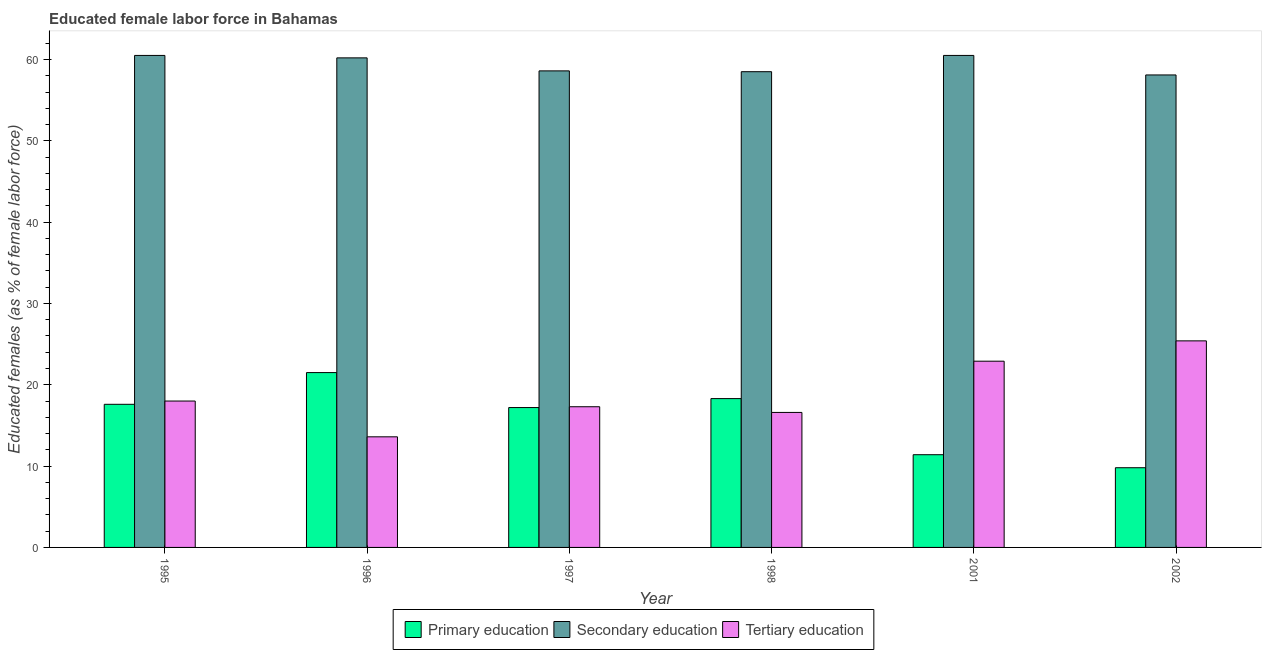Are the number of bars on each tick of the X-axis equal?
Provide a succinct answer. Yes. What is the label of the 6th group of bars from the left?
Ensure brevity in your answer.  2002. What is the percentage of female labor force who received primary education in 1997?
Make the answer very short. 17.2. Across all years, what is the maximum percentage of female labor force who received secondary education?
Keep it short and to the point. 60.5. Across all years, what is the minimum percentage of female labor force who received primary education?
Your response must be concise. 9.8. In which year was the percentage of female labor force who received primary education minimum?
Your answer should be very brief. 2002. What is the total percentage of female labor force who received primary education in the graph?
Offer a terse response. 95.8. What is the difference between the percentage of female labor force who received tertiary education in 1996 and that in 1998?
Provide a short and direct response. -3. What is the average percentage of female labor force who received secondary education per year?
Offer a terse response. 59.4. In how many years, is the percentage of female labor force who received primary education greater than 46 %?
Your answer should be compact. 0. What is the ratio of the percentage of female labor force who received primary education in 1995 to that in 1996?
Give a very brief answer. 0.82. Is the percentage of female labor force who received primary education in 1995 less than that in 2001?
Give a very brief answer. No. Is the difference between the percentage of female labor force who received primary education in 1997 and 1998 greater than the difference between the percentage of female labor force who received secondary education in 1997 and 1998?
Ensure brevity in your answer.  No. What is the difference between the highest and the second highest percentage of female labor force who received primary education?
Keep it short and to the point. 3.2. What is the difference between the highest and the lowest percentage of female labor force who received tertiary education?
Make the answer very short. 11.8. In how many years, is the percentage of female labor force who received primary education greater than the average percentage of female labor force who received primary education taken over all years?
Your answer should be very brief. 4. What does the 3rd bar from the left in 1998 represents?
Offer a very short reply. Tertiary education. What does the 1st bar from the right in 1995 represents?
Provide a short and direct response. Tertiary education. Is it the case that in every year, the sum of the percentage of female labor force who received primary education and percentage of female labor force who received secondary education is greater than the percentage of female labor force who received tertiary education?
Ensure brevity in your answer.  Yes. Are all the bars in the graph horizontal?
Your response must be concise. No. Are the values on the major ticks of Y-axis written in scientific E-notation?
Your answer should be compact. No. Does the graph contain any zero values?
Ensure brevity in your answer.  No. Does the graph contain grids?
Make the answer very short. No. How many legend labels are there?
Offer a very short reply. 3. How are the legend labels stacked?
Offer a very short reply. Horizontal. What is the title of the graph?
Provide a succinct answer. Educated female labor force in Bahamas. What is the label or title of the Y-axis?
Your answer should be compact. Educated females (as % of female labor force). What is the Educated females (as % of female labor force) of Primary education in 1995?
Provide a short and direct response. 17.6. What is the Educated females (as % of female labor force) of Secondary education in 1995?
Your response must be concise. 60.5. What is the Educated females (as % of female labor force) of Tertiary education in 1995?
Provide a succinct answer. 18. What is the Educated females (as % of female labor force) in Primary education in 1996?
Offer a terse response. 21.5. What is the Educated females (as % of female labor force) in Secondary education in 1996?
Ensure brevity in your answer.  60.2. What is the Educated females (as % of female labor force) of Tertiary education in 1996?
Ensure brevity in your answer.  13.6. What is the Educated females (as % of female labor force) in Primary education in 1997?
Make the answer very short. 17.2. What is the Educated females (as % of female labor force) in Secondary education in 1997?
Provide a short and direct response. 58.6. What is the Educated females (as % of female labor force) of Tertiary education in 1997?
Give a very brief answer. 17.3. What is the Educated females (as % of female labor force) in Primary education in 1998?
Your answer should be very brief. 18.3. What is the Educated females (as % of female labor force) in Secondary education in 1998?
Offer a terse response. 58.5. What is the Educated females (as % of female labor force) of Tertiary education in 1998?
Offer a very short reply. 16.6. What is the Educated females (as % of female labor force) of Primary education in 2001?
Make the answer very short. 11.4. What is the Educated females (as % of female labor force) of Secondary education in 2001?
Your response must be concise. 60.5. What is the Educated females (as % of female labor force) of Tertiary education in 2001?
Your answer should be compact. 22.9. What is the Educated females (as % of female labor force) of Primary education in 2002?
Make the answer very short. 9.8. What is the Educated females (as % of female labor force) of Secondary education in 2002?
Your answer should be compact. 58.1. What is the Educated females (as % of female labor force) in Tertiary education in 2002?
Your response must be concise. 25.4. Across all years, what is the maximum Educated females (as % of female labor force) of Primary education?
Your answer should be very brief. 21.5. Across all years, what is the maximum Educated females (as % of female labor force) in Secondary education?
Your answer should be very brief. 60.5. Across all years, what is the maximum Educated females (as % of female labor force) in Tertiary education?
Make the answer very short. 25.4. Across all years, what is the minimum Educated females (as % of female labor force) of Primary education?
Offer a terse response. 9.8. Across all years, what is the minimum Educated females (as % of female labor force) of Secondary education?
Your response must be concise. 58.1. Across all years, what is the minimum Educated females (as % of female labor force) in Tertiary education?
Your answer should be compact. 13.6. What is the total Educated females (as % of female labor force) of Primary education in the graph?
Your response must be concise. 95.8. What is the total Educated females (as % of female labor force) in Secondary education in the graph?
Ensure brevity in your answer.  356.4. What is the total Educated females (as % of female labor force) in Tertiary education in the graph?
Provide a short and direct response. 113.8. What is the difference between the Educated females (as % of female labor force) of Primary education in 1995 and that in 1997?
Provide a succinct answer. 0.4. What is the difference between the Educated females (as % of female labor force) of Secondary education in 1995 and that in 1997?
Offer a terse response. 1.9. What is the difference between the Educated females (as % of female labor force) of Tertiary education in 1995 and that in 1997?
Offer a terse response. 0.7. What is the difference between the Educated females (as % of female labor force) in Secondary education in 1995 and that in 1998?
Your answer should be compact. 2. What is the difference between the Educated females (as % of female labor force) in Tertiary education in 1995 and that in 1998?
Your response must be concise. 1.4. What is the difference between the Educated females (as % of female labor force) in Tertiary education in 1995 and that in 2001?
Ensure brevity in your answer.  -4.9. What is the difference between the Educated females (as % of female labor force) in Primary education in 1996 and that in 1997?
Your answer should be compact. 4.3. What is the difference between the Educated females (as % of female labor force) in Tertiary education in 1996 and that in 1997?
Your answer should be very brief. -3.7. What is the difference between the Educated females (as % of female labor force) of Primary education in 1996 and that in 1998?
Your answer should be very brief. 3.2. What is the difference between the Educated females (as % of female labor force) of Primary education in 1996 and that in 2001?
Your answer should be very brief. 10.1. What is the difference between the Educated females (as % of female labor force) in Secondary education in 1996 and that in 2001?
Make the answer very short. -0.3. What is the difference between the Educated females (as % of female labor force) in Tertiary education in 1996 and that in 2001?
Offer a terse response. -9.3. What is the difference between the Educated females (as % of female labor force) of Primary education in 1996 and that in 2002?
Make the answer very short. 11.7. What is the difference between the Educated females (as % of female labor force) in Secondary education in 1996 and that in 2002?
Provide a succinct answer. 2.1. What is the difference between the Educated females (as % of female labor force) in Secondary education in 1997 and that in 1998?
Provide a short and direct response. 0.1. What is the difference between the Educated females (as % of female labor force) of Tertiary education in 1997 and that in 1998?
Your response must be concise. 0.7. What is the difference between the Educated females (as % of female labor force) of Secondary education in 1997 and that in 2001?
Provide a succinct answer. -1.9. What is the difference between the Educated females (as % of female labor force) of Tertiary education in 1997 and that in 2001?
Provide a short and direct response. -5.6. What is the difference between the Educated females (as % of female labor force) of Primary education in 1997 and that in 2002?
Your response must be concise. 7.4. What is the difference between the Educated females (as % of female labor force) of Secondary education in 1997 and that in 2002?
Offer a terse response. 0.5. What is the difference between the Educated females (as % of female labor force) in Tertiary education in 1998 and that in 2001?
Keep it short and to the point. -6.3. What is the difference between the Educated females (as % of female labor force) in Primary education in 1998 and that in 2002?
Make the answer very short. 8.5. What is the difference between the Educated females (as % of female labor force) of Secondary education in 2001 and that in 2002?
Ensure brevity in your answer.  2.4. What is the difference between the Educated females (as % of female labor force) of Tertiary education in 2001 and that in 2002?
Your response must be concise. -2.5. What is the difference between the Educated females (as % of female labor force) of Primary education in 1995 and the Educated females (as % of female labor force) of Secondary education in 1996?
Your answer should be compact. -42.6. What is the difference between the Educated females (as % of female labor force) of Primary education in 1995 and the Educated females (as % of female labor force) of Tertiary education in 1996?
Provide a succinct answer. 4. What is the difference between the Educated females (as % of female labor force) in Secondary education in 1995 and the Educated females (as % of female labor force) in Tertiary education in 1996?
Make the answer very short. 46.9. What is the difference between the Educated females (as % of female labor force) in Primary education in 1995 and the Educated females (as % of female labor force) in Secondary education in 1997?
Provide a succinct answer. -41. What is the difference between the Educated females (as % of female labor force) in Primary education in 1995 and the Educated females (as % of female labor force) in Tertiary education in 1997?
Give a very brief answer. 0.3. What is the difference between the Educated females (as % of female labor force) of Secondary education in 1995 and the Educated females (as % of female labor force) of Tertiary education in 1997?
Your answer should be compact. 43.2. What is the difference between the Educated females (as % of female labor force) in Primary education in 1995 and the Educated females (as % of female labor force) in Secondary education in 1998?
Offer a very short reply. -40.9. What is the difference between the Educated females (as % of female labor force) in Primary education in 1995 and the Educated females (as % of female labor force) in Tertiary education in 1998?
Your answer should be compact. 1. What is the difference between the Educated females (as % of female labor force) in Secondary education in 1995 and the Educated females (as % of female labor force) in Tertiary education in 1998?
Offer a terse response. 43.9. What is the difference between the Educated females (as % of female labor force) in Primary education in 1995 and the Educated females (as % of female labor force) in Secondary education in 2001?
Your response must be concise. -42.9. What is the difference between the Educated females (as % of female labor force) in Primary education in 1995 and the Educated females (as % of female labor force) in Tertiary education in 2001?
Keep it short and to the point. -5.3. What is the difference between the Educated females (as % of female labor force) of Secondary education in 1995 and the Educated females (as % of female labor force) of Tertiary education in 2001?
Your answer should be compact. 37.6. What is the difference between the Educated females (as % of female labor force) in Primary education in 1995 and the Educated females (as % of female labor force) in Secondary education in 2002?
Your answer should be very brief. -40.5. What is the difference between the Educated females (as % of female labor force) of Primary education in 1995 and the Educated females (as % of female labor force) of Tertiary education in 2002?
Give a very brief answer. -7.8. What is the difference between the Educated females (as % of female labor force) in Secondary education in 1995 and the Educated females (as % of female labor force) in Tertiary education in 2002?
Ensure brevity in your answer.  35.1. What is the difference between the Educated females (as % of female labor force) of Primary education in 1996 and the Educated females (as % of female labor force) of Secondary education in 1997?
Offer a very short reply. -37.1. What is the difference between the Educated females (as % of female labor force) in Secondary education in 1996 and the Educated females (as % of female labor force) in Tertiary education in 1997?
Make the answer very short. 42.9. What is the difference between the Educated females (as % of female labor force) of Primary education in 1996 and the Educated females (as % of female labor force) of Secondary education in 1998?
Your response must be concise. -37. What is the difference between the Educated females (as % of female labor force) in Secondary education in 1996 and the Educated females (as % of female labor force) in Tertiary education in 1998?
Offer a terse response. 43.6. What is the difference between the Educated females (as % of female labor force) in Primary education in 1996 and the Educated females (as % of female labor force) in Secondary education in 2001?
Your answer should be compact. -39. What is the difference between the Educated females (as % of female labor force) in Primary education in 1996 and the Educated females (as % of female labor force) in Tertiary education in 2001?
Offer a terse response. -1.4. What is the difference between the Educated females (as % of female labor force) in Secondary education in 1996 and the Educated females (as % of female labor force) in Tertiary education in 2001?
Your response must be concise. 37.3. What is the difference between the Educated females (as % of female labor force) of Primary education in 1996 and the Educated females (as % of female labor force) of Secondary education in 2002?
Ensure brevity in your answer.  -36.6. What is the difference between the Educated females (as % of female labor force) of Secondary education in 1996 and the Educated females (as % of female labor force) of Tertiary education in 2002?
Provide a short and direct response. 34.8. What is the difference between the Educated females (as % of female labor force) in Primary education in 1997 and the Educated females (as % of female labor force) in Secondary education in 1998?
Give a very brief answer. -41.3. What is the difference between the Educated females (as % of female labor force) of Primary education in 1997 and the Educated females (as % of female labor force) of Tertiary education in 1998?
Your response must be concise. 0.6. What is the difference between the Educated females (as % of female labor force) of Primary education in 1997 and the Educated females (as % of female labor force) of Secondary education in 2001?
Your answer should be very brief. -43.3. What is the difference between the Educated females (as % of female labor force) in Secondary education in 1997 and the Educated females (as % of female labor force) in Tertiary education in 2001?
Your answer should be very brief. 35.7. What is the difference between the Educated females (as % of female labor force) in Primary education in 1997 and the Educated females (as % of female labor force) in Secondary education in 2002?
Offer a very short reply. -40.9. What is the difference between the Educated females (as % of female labor force) of Primary education in 1997 and the Educated females (as % of female labor force) of Tertiary education in 2002?
Provide a succinct answer. -8.2. What is the difference between the Educated females (as % of female labor force) of Secondary education in 1997 and the Educated females (as % of female labor force) of Tertiary education in 2002?
Your answer should be very brief. 33.2. What is the difference between the Educated females (as % of female labor force) of Primary education in 1998 and the Educated females (as % of female labor force) of Secondary education in 2001?
Give a very brief answer. -42.2. What is the difference between the Educated females (as % of female labor force) of Secondary education in 1998 and the Educated females (as % of female labor force) of Tertiary education in 2001?
Your response must be concise. 35.6. What is the difference between the Educated females (as % of female labor force) in Primary education in 1998 and the Educated females (as % of female labor force) in Secondary education in 2002?
Offer a very short reply. -39.8. What is the difference between the Educated females (as % of female labor force) of Secondary education in 1998 and the Educated females (as % of female labor force) of Tertiary education in 2002?
Give a very brief answer. 33.1. What is the difference between the Educated females (as % of female labor force) in Primary education in 2001 and the Educated females (as % of female labor force) in Secondary education in 2002?
Ensure brevity in your answer.  -46.7. What is the difference between the Educated females (as % of female labor force) of Primary education in 2001 and the Educated females (as % of female labor force) of Tertiary education in 2002?
Your response must be concise. -14. What is the difference between the Educated females (as % of female labor force) in Secondary education in 2001 and the Educated females (as % of female labor force) in Tertiary education in 2002?
Offer a terse response. 35.1. What is the average Educated females (as % of female labor force) of Primary education per year?
Provide a short and direct response. 15.97. What is the average Educated females (as % of female labor force) of Secondary education per year?
Make the answer very short. 59.4. What is the average Educated females (as % of female labor force) in Tertiary education per year?
Make the answer very short. 18.97. In the year 1995, what is the difference between the Educated females (as % of female labor force) in Primary education and Educated females (as % of female labor force) in Secondary education?
Provide a succinct answer. -42.9. In the year 1995, what is the difference between the Educated females (as % of female labor force) in Primary education and Educated females (as % of female labor force) in Tertiary education?
Your answer should be very brief. -0.4. In the year 1995, what is the difference between the Educated females (as % of female labor force) of Secondary education and Educated females (as % of female labor force) of Tertiary education?
Give a very brief answer. 42.5. In the year 1996, what is the difference between the Educated females (as % of female labor force) in Primary education and Educated females (as % of female labor force) in Secondary education?
Provide a short and direct response. -38.7. In the year 1996, what is the difference between the Educated females (as % of female labor force) of Primary education and Educated females (as % of female labor force) of Tertiary education?
Ensure brevity in your answer.  7.9. In the year 1996, what is the difference between the Educated females (as % of female labor force) of Secondary education and Educated females (as % of female labor force) of Tertiary education?
Provide a short and direct response. 46.6. In the year 1997, what is the difference between the Educated females (as % of female labor force) of Primary education and Educated females (as % of female labor force) of Secondary education?
Give a very brief answer. -41.4. In the year 1997, what is the difference between the Educated females (as % of female labor force) of Primary education and Educated females (as % of female labor force) of Tertiary education?
Give a very brief answer. -0.1. In the year 1997, what is the difference between the Educated females (as % of female labor force) of Secondary education and Educated females (as % of female labor force) of Tertiary education?
Your answer should be very brief. 41.3. In the year 1998, what is the difference between the Educated females (as % of female labor force) in Primary education and Educated females (as % of female labor force) in Secondary education?
Provide a short and direct response. -40.2. In the year 1998, what is the difference between the Educated females (as % of female labor force) in Primary education and Educated females (as % of female labor force) in Tertiary education?
Make the answer very short. 1.7. In the year 1998, what is the difference between the Educated females (as % of female labor force) of Secondary education and Educated females (as % of female labor force) of Tertiary education?
Keep it short and to the point. 41.9. In the year 2001, what is the difference between the Educated females (as % of female labor force) in Primary education and Educated females (as % of female labor force) in Secondary education?
Your response must be concise. -49.1. In the year 2001, what is the difference between the Educated females (as % of female labor force) in Primary education and Educated females (as % of female labor force) in Tertiary education?
Your answer should be compact. -11.5. In the year 2001, what is the difference between the Educated females (as % of female labor force) in Secondary education and Educated females (as % of female labor force) in Tertiary education?
Offer a very short reply. 37.6. In the year 2002, what is the difference between the Educated females (as % of female labor force) of Primary education and Educated females (as % of female labor force) of Secondary education?
Offer a very short reply. -48.3. In the year 2002, what is the difference between the Educated females (as % of female labor force) in Primary education and Educated females (as % of female labor force) in Tertiary education?
Make the answer very short. -15.6. In the year 2002, what is the difference between the Educated females (as % of female labor force) in Secondary education and Educated females (as % of female labor force) in Tertiary education?
Your answer should be compact. 32.7. What is the ratio of the Educated females (as % of female labor force) in Primary education in 1995 to that in 1996?
Offer a very short reply. 0.82. What is the ratio of the Educated females (as % of female labor force) of Tertiary education in 1995 to that in 1996?
Keep it short and to the point. 1.32. What is the ratio of the Educated females (as % of female labor force) in Primary education in 1995 to that in 1997?
Make the answer very short. 1.02. What is the ratio of the Educated females (as % of female labor force) of Secondary education in 1995 to that in 1997?
Offer a terse response. 1.03. What is the ratio of the Educated females (as % of female labor force) in Tertiary education in 1995 to that in 1997?
Provide a succinct answer. 1.04. What is the ratio of the Educated females (as % of female labor force) of Primary education in 1995 to that in 1998?
Offer a very short reply. 0.96. What is the ratio of the Educated females (as % of female labor force) of Secondary education in 1995 to that in 1998?
Your response must be concise. 1.03. What is the ratio of the Educated females (as % of female labor force) in Tertiary education in 1995 to that in 1998?
Provide a succinct answer. 1.08. What is the ratio of the Educated females (as % of female labor force) in Primary education in 1995 to that in 2001?
Your answer should be compact. 1.54. What is the ratio of the Educated females (as % of female labor force) of Tertiary education in 1995 to that in 2001?
Provide a succinct answer. 0.79. What is the ratio of the Educated females (as % of female labor force) of Primary education in 1995 to that in 2002?
Provide a short and direct response. 1.8. What is the ratio of the Educated females (as % of female labor force) in Secondary education in 1995 to that in 2002?
Offer a very short reply. 1.04. What is the ratio of the Educated females (as % of female labor force) of Tertiary education in 1995 to that in 2002?
Ensure brevity in your answer.  0.71. What is the ratio of the Educated females (as % of female labor force) of Secondary education in 1996 to that in 1997?
Your response must be concise. 1.03. What is the ratio of the Educated females (as % of female labor force) of Tertiary education in 1996 to that in 1997?
Provide a short and direct response. 0.79. What is the ratio of the Educated females (as % of female labor force) of Primary education in 1996 to that in 1998?
Offer a terse response. 1.17. What is the ratio of the Educated females (as % of female labor force) in Secondary education in 1996 to that in 1998?
Your answer should be compact. 1.03. What is the ratio of the Educated females (as % of female labor force) in Tertiary education in 1996 to that in 1998?
Your response must be concise. 0.82. What is the ratio of the Educated females (as % of female labor force) of Primary education in 1996 to that in 2001?
Your answer should be compact. 1.89. What is the ratio of the Educated females (as % of female labor force) in Tertiary education in 1996 to that in 2001?
Provide a short and direct response. 0.59. What is the ratio of the Educated females (as % of female labor force) of Primary education in 1996 to that in 2002?
Give a very brief answer. 2.19. What is the ratio of the Educated females (as % of female labor force) in Secondary education in 1996 to that in 2002?
Make the answer very short. 1.04. What is the ratio of the Educated females (as % of female labor force) of Tertiary education in 1996 to that in 2002?
Provide a succinct answer. 0.54. What is the ratio of the Educated females (as % of female labor force) in Primary education in 1997 to that in 1998?
Keep it short and to the point. 0.94. What is the ratio of the Educated females (as % of female labor force) in Tertiary education in 1997 to that in 1998?
Provide a short and direct response. 1.04. What is the ratio of the Educated females (as % of female labor force) in Primary education in 1997 to that in 2001?
Your answer should be very brief. 1.51. What is the ratio of the Educated females (as % of female labor force) of Secondary education in 1997 to that in 2001?
Offer a very short reply. 0.97. What is the ratio of the Educated females (as % of female labor force) of Tertiary education in 1997 to that in 2001?
Make the answer very short. 0.76. What is the ratio of the Educated females (as % of female labor force) in Primary education in 1997 to that in 2002?
Offer a terse response. 1.76. What is the ratio of the Educated females (as % of female labor force) of Secondary education in 1997 to that in 2002?
Offer a terse response. 1.01. What is the ratio of the Educated females (as % of female labor force) of Tertiary education in 1997 to that in 2002?
Keep it short and to the point. 0.68. What is the ratio of the Educated females (as % of female labor force) of Primary education in 1998 to that in 2001?
Offer a very short reply. 1.61. What is the ratio of the Educated females (as % of female labor force) in Secondary education in 1998 to that in 2001?
Your response must be concise. 0.97. What is the ratio of the Educated females (as % of female labor force) in Tertiary education in 1998 to that in 2001?
Keep it short and to the point. 0.72. What is the ratio of the Educated females (as % of female labor force) in Primary education in 1998 to that in 2002?
Provide a short and direct response. 1.87. What is the ratio of the Educated females (as % of female labor force) of Tertiary education in 1998 to that in 2002?
Your answer should be very brief. 0.65. What is the ratio of the Educated females (as % of female labor force) in Primary education in 2001 to that in 2002?
Keep it short and to the point. 1.16. What is the ratio of the Educated females (as % of female labor force) of Secondary education in 2001 to that in 2002?
Make the answer very short. 1.04. What is the ratio of the Educated females (as % of female labor force) of Tertiary education in 2001 to that in 2002?
Your response must be concise. 0.9. What is the difference between the highest and the second highest Educated females (as % of female labor force) of Secondary education?
Provide a succinct answer. 0. What is the difference between the highest and the second highest Educated females (as % of female labor force) of Tertiary education?
Keep it short and to the point. 2.5. What is the difference between the highest and the lowest Educated females (as % of female labor force) of Secondary education?
Provide a short and direct response. 2.4. 